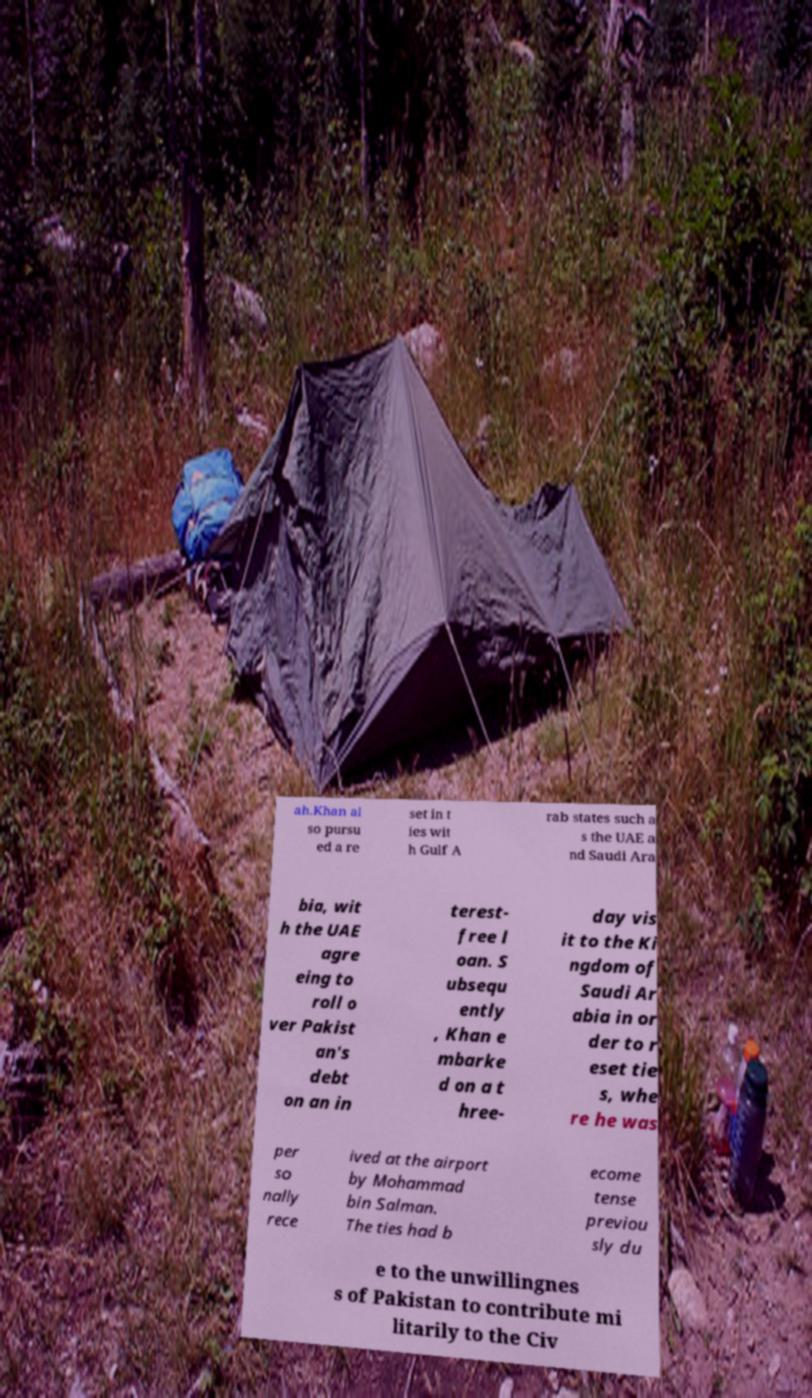Can you accurately transcribe the text from the provided image for me? ah.Khan al so pursu ed a re set in t ies wit h Gulf A rab states such a s the UAE a nd Saudi Ara bia, wit h the UAE agre eing to roll o ver Pakist an's debt on an in terest- free l oan. S ubsequ ently , Khan e mbarke d on a t hree- day vis it to the Ki ngdom of Saudi Ar abia in or der to r eset tie s, whe re he was per so nally rece ived at the airport by Mohammad bin Salman. The ties had b ecome tense previou sly du e to the unwillingnes s of Pakistan to contribute mi litarily to the Civ 